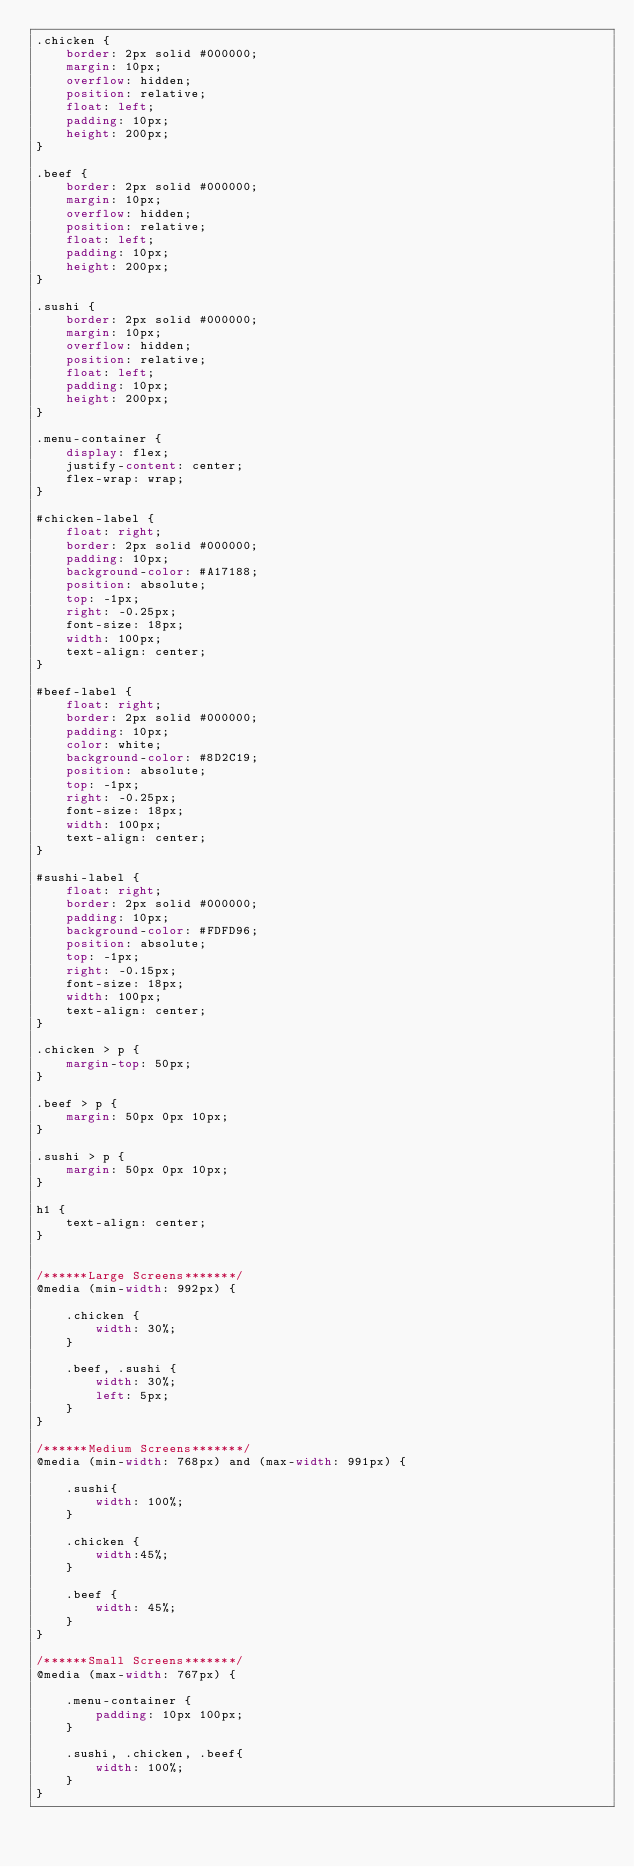<code> <loc_0><loc_0><loc_500><loc_500><_CSS_>.chicken {
	border: 2px solid #000000;
	margin: 10px;
	overflow: hidden;
	position: relative;
  	float: left;
 	padding: 10px;
 	height: 200px;
}

.beef {
	border: 2px solid #000000;
	margin: 10px;
	overflow: hidden;
	position: relative;
  	float: left;
 	padding: 10px;
 	height: 200px;
}

.sushi {
	border: 2px solid #000000;
	margin: 10px;
	overflow: hidden;
	position: relative;
  	float: left;
 	padding: 10px;
 	height: 200px;
}

.menu-container {
  	display: flex;
  	justify-content: center;
  	flex-wrap: wrap;
}

#chicken-label {
	float: right;
	border: 2px solid #000000;
	padding: 10px;
	background-color: #A17188;
	position: absolute;
	top: -1px;
	right: -0.25px;
	font-size: 18px;
	width: 100px;
	text-align: center;
}

#beef-label {
	float: right;
	border: 2px solid #000000;
	padding: 10px;
	color: white;
	background-color: #8D2C19;
	position: absolute;
  	top: -1px;
  	right: -0.25px;
  	font-size: 18px;
  	width: 100px;
	text-align: center;
}

#sushi-label {
	float: right;
	border: 2px solid #000000;
	padding: 10px;
	background-color: #FDFD96;
	position: absolute;
  	top: -1px;
  	right: -0.15px;
  	font-size: 18px;
  	width: 100px;
  	text-align: center;
}

.chicken > p {
	margin-top: 50px;
}

.beef > p {
	margin: 50px 0px 10px;
}

.sushi > p {
	margin: 50px 0px 10px;
}

h1 {
	text-align: center;
}


/******Large Screens*******/
@media (min-width: 992px) {

	.chicken {
		width: 30%;
	}

	.beef, .sushi {
		width: 30%;
		left: 5px;
	}
}

/******Medium Screens*******/
@media (min-width: 768px) and (max-width: 991px) {
  	
  	.sushi{
    	width: 100%;
  	}

  	.chicken {
  		width:45%;
  	}

  	.beef {
  		width: 45%;
  	}
}

/******Small Screens*******/
@media (max-width: 767px) {
  	
  	.menu-container {
		padding: 10px 100px;
  	}

  	.sushi, .chicken, .beef{
    	width: 100%;
    }
}</code> 